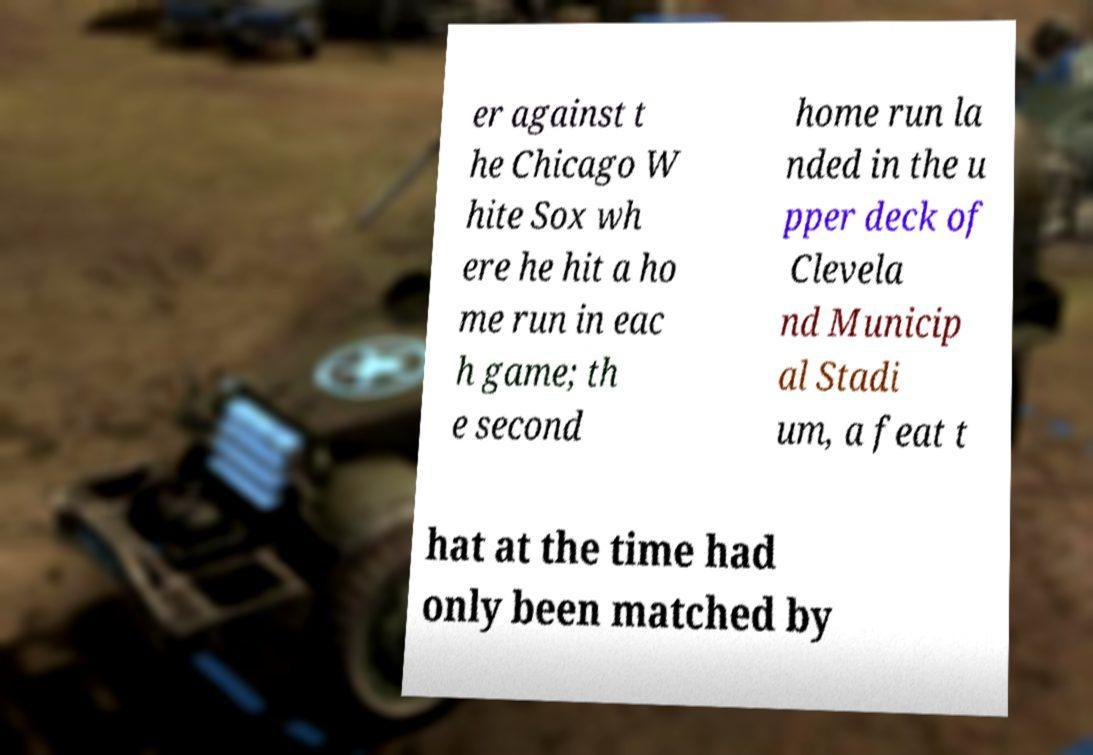I need the written content from this picture converted into text. Can you do that? er against t he Chicago W hite Sox wh ere he hit a ho me run in eac h game; th e second home run la nded in the u pper deck of Clevela nd Municip al Stadi um, a feat t hat at the time had only been matched by 